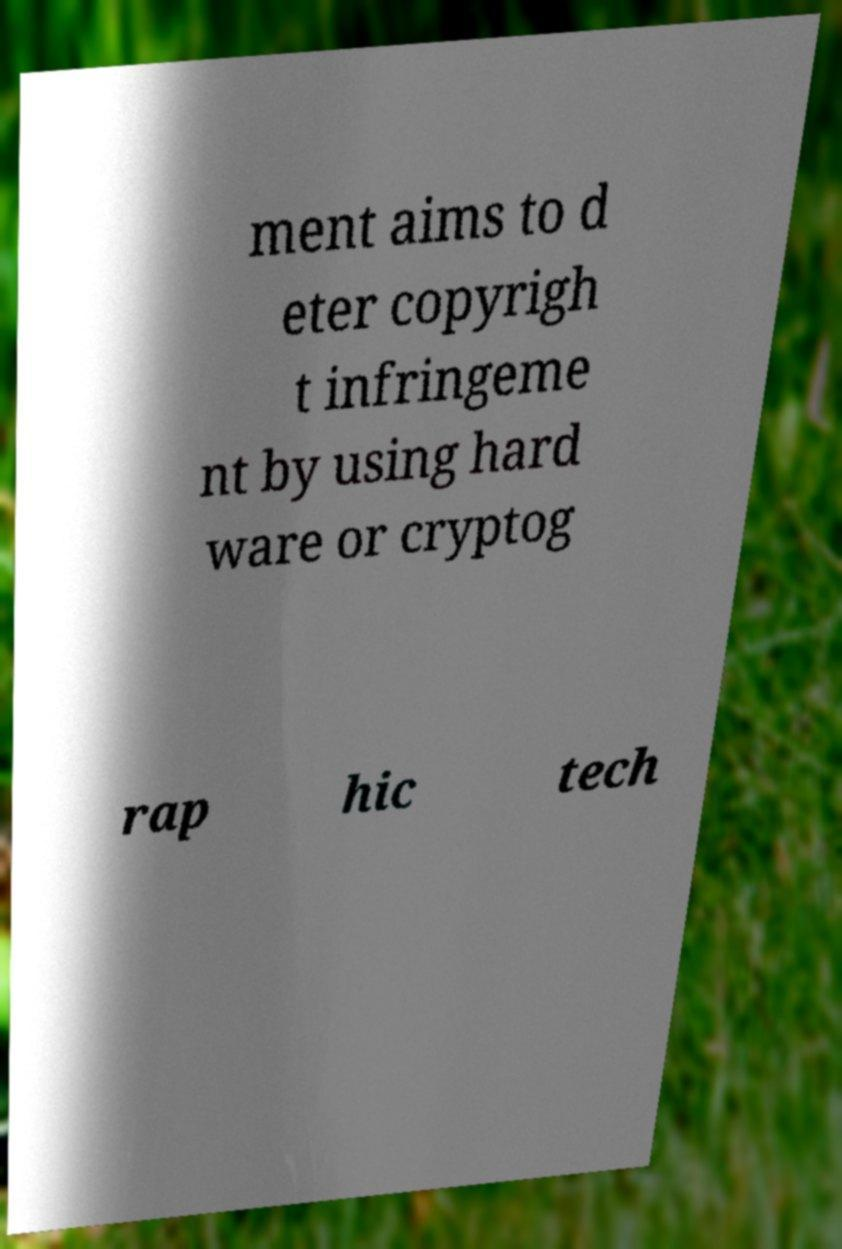What messages or text are displayed in this image? I need them in a readable, typed format. ment aims to d eter copyrigh t infringeme nt by using hard ware or cryptog rap hic tech 